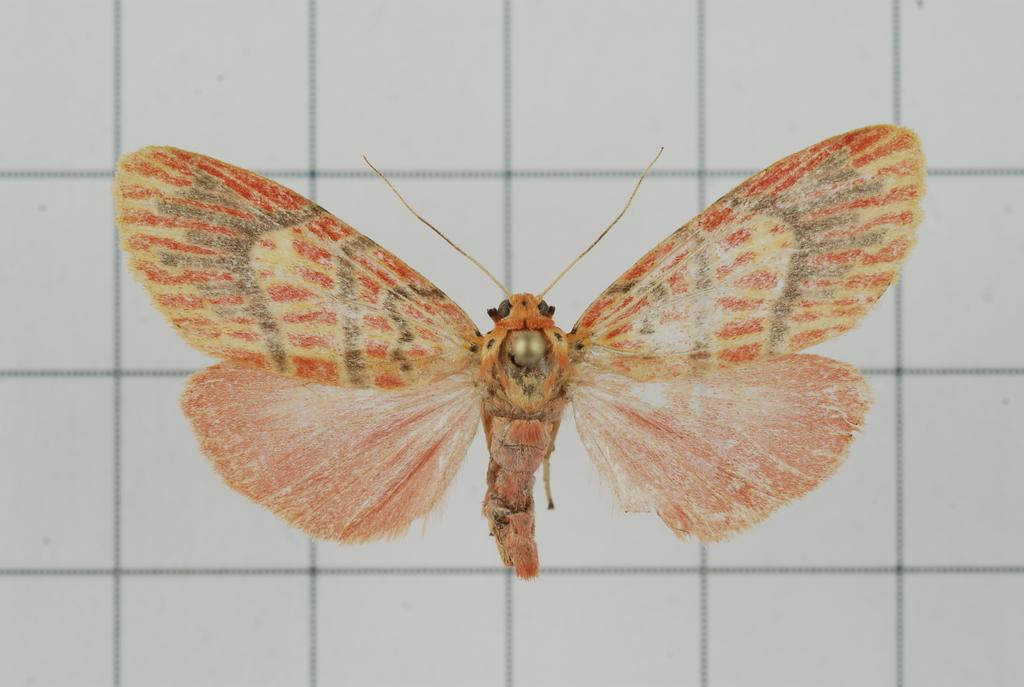What is the main subject of the picture? The main subject of the picture is a butterfly. What can be seen in the background of the picture? There is a wall in the background of the picture. What sense does the butterfly use to detect the presence of the wall in the image? Butterflies do not have the ability to detect walls in images, as they are living organisms and not capable of understanding visual representations. 